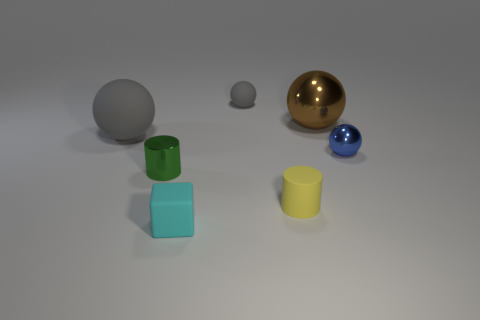Add 2 tiny blue matte things. How many objects exist? 9 Subtract all balls. How many objects are left? 3 Subtract all large red shiny spheres. Subtract all small cubes. How many objects are left? 6 Add 2 large rubber balls. How many large rubber balls are left? 3 Add 5 gray rubber balls. How many gray rubber balls exist? 7 Subtract 0 blue blocks. How many objects are left? 7 